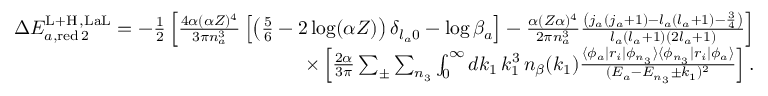<formula> <loc_0><loc_0><loc_500><loc_500>\begin{array} { r } { \Delta E _ { a , r e d \, 2 } ^ { L + H \, , L a L } = - \frac { 1 } { 2 } \left [ \frac { 4 \alpha ( \alpha Z ) ^ { 4 } } { 3 \pi n _ { a } ^ { 3 } } \left [ \left ( \frac { 5 } { 6 } - 2 \log ( \alpha Z ) \right ) \delta _ { l _ { a } 0 } - \log \beta _ { a } \right ] - \frac { \alpha ( Z \alpha ) ^ { 4 } } { 2 \pi n _ { a } ^ { 3 } } \frac { \left ( j _ { a } ( j _ { a } + 1 ) - l _ { a } ( l _ { a } + 1 ) - \frac { 3 } { 4 } \right ) } { l _ { a } ( l _ { a } + 1 ) ( 2 l _ { a } + 1 ) } \right ] } \\ { \times \left [ \frac { 2 \alpha } { 3 \pi } \sum _ { \pm } \sum _ { n _ { 3 } } \int _ { 0 } ^ { \infty } d k _ { 1 } \, k _ { 1 } ^ { 3 } \, n _ { \beta } ( k _ { 1 } ) \frac { \langle \phi _ { a } | r _ { i } | \phi _ { n _ { 3 } } \rangle \langle \phi _ { n _ { 3 } } | r _ { i } | \phi _ { a } \rangle } { ( E _ { a } - E _ { n _ { 3 } } \pm k _ { 1 } ) ^ { 2 } } \right ] . } \end{array}</formula> 